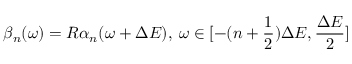Convert formula to latex. <formula><loc_0><loc_0><loc_500><loc_500>\beta _ { n } ( \omega ) = R \alpha _ { n } ( \omega + \Delta E ) , \, \omega \in [ - ( n + \frac { 1 } { 2 } ) \Delta E , \frac { \Delta E } { 2 } ]</formula> 